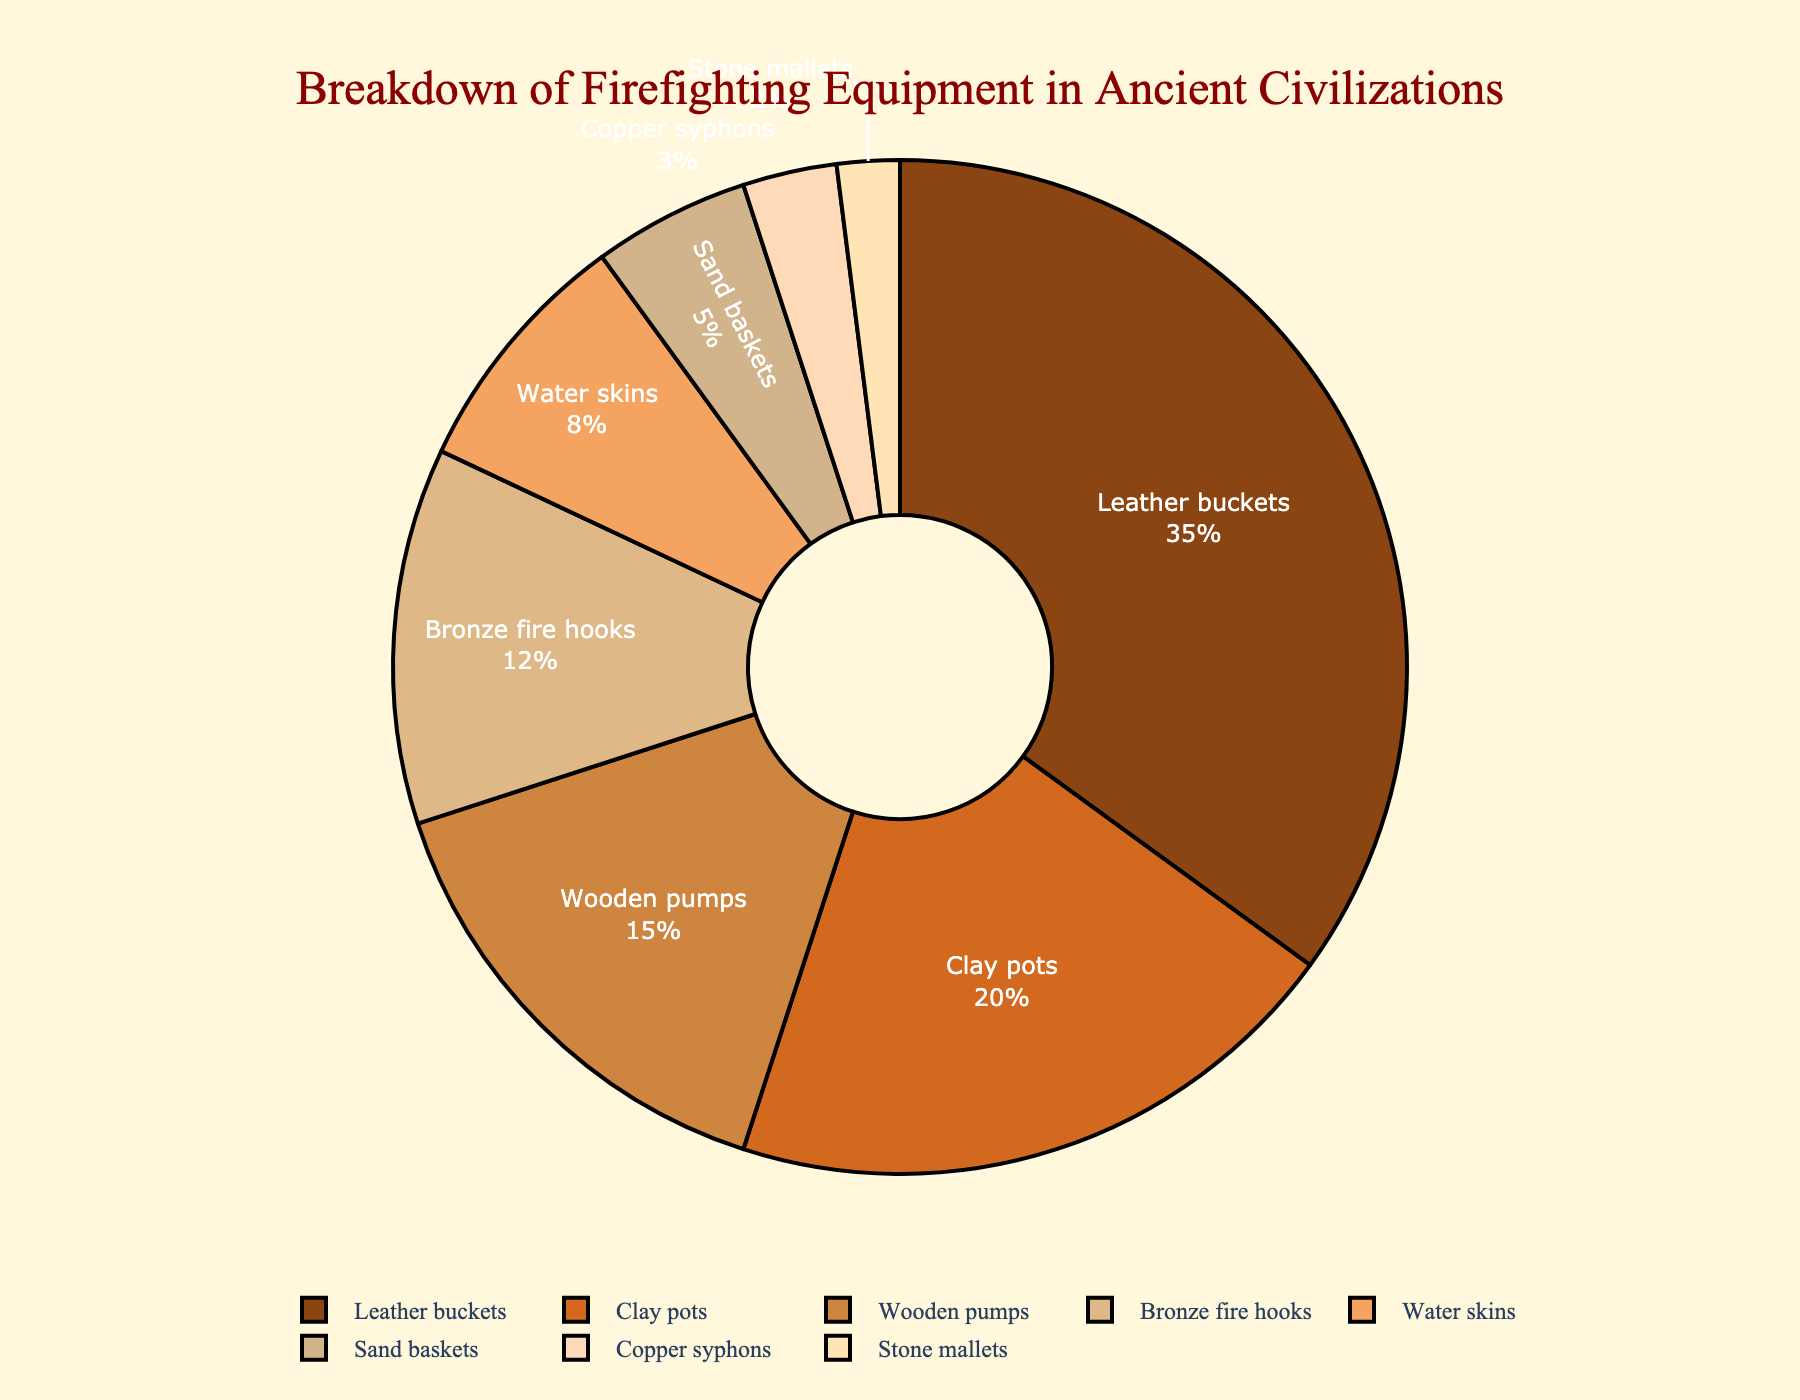What percentage of the firefighting equipment was made of bronze? The pie chart shows "Bronze fire hooks" and indicates their percentage is 12%.
Answer: 12% Which equipment category had the smallest percentage? By observing the pie chart, "Stone mallets" have the smallest segment, indicating their percentage is 2%.
Answer: Stone mallets How much more common were leather buckets than clay pots? Leather buckets are 35% and clay pots are 20%. The difference is 35% - 20% = 15%.
Answer: 15% Are wooden pumps more or less common than water skins? The pie chart shows "Wooden pumps" at 15% and "Water skins" at 8%. Wooden pumps are more common.
Answer: More common What visual attribute indicates the prevalence of leather buckets compared to other equipment? Leather buckets occupy the largest section of the chart, visually indicating they are the most prevalent.
Answer: Largest section If you sum the percentages of bronze fire hooks and sand baskets, what do you get? Bronze fire hooks are 12% and sand baskets are 5%. Summing these, 12% + 5% = 17%.
Answer: 17% Is the percentage of clay pots closer to that of wooden pumps or bronze fire hooks? Clay pots are 20%. Wooden pumps are 15%, and bronze fire hooks are 12%. The difference with wooden pumps is 20% - 15% = 5%, and with bronze fire hooks, it's 20% - 12% = 8%. Clay pots are closer to wooden pumps.
Answer: Wooden pumps Which two equipment categories combined have a percentage equal to or just above 10%? Water skins are 8% and copper syphons are 3%. Summing these, 8% + 3% = 11%, which is just above 10%.
Answer: Water skins and copper syphons Among the listed equipment, which has a percentage twice that of sand baskets? Sand baskets are 5%. Double of this is 5% × 2 = 10%. Water skins are 8%, which is the closest higher value, but still less than twice 5%. No equipment exactly meets this criterion.
Answer: None meets exactly What are the total percentages for leather buckets, clay pots, and wooden pumps combined? Leather buckets are 35%, clay pots are 20%, and wooden pumps are 15%. Summing these, 35% + 20% + 15% = 70%.
Answer: 70% 